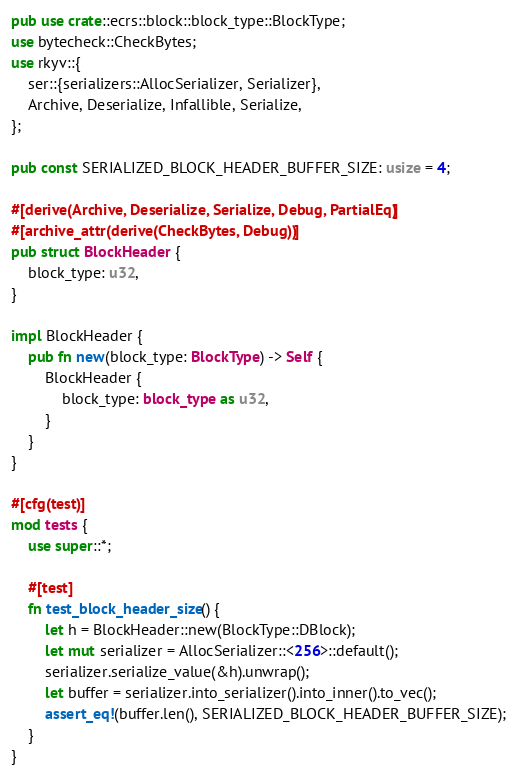Convert code to text. <code><loc_0><loc_0><loc_500><loc_500><_Rust_>pub use crate::ecrs::block::block_type::BlockType;
use bytecheck::CheckBytes;
use rkyv::{
    ser::{serializers::AllocSerializer, Serializer},
    Archive, Deserialize, Infallible, Serialize,
};

pub const SERIALIZED_BLOCK_HEADER_BUFFER_SIZE: usize = 4;

#[derive(Archive, Deserialize, Serialize, Debug, PartialEq)]
#[archive_attr(derive(CheckBytes, Debug))]
pub struct BlockHeader {
    block_type: u32,
}

impl BlockHeader {
    pub fn new(block_type: BlockType) -> Self {
        BlockHeader {
            block_type: block_type as u32,
        }
    }
}

#[cfg(test)]
mod tests {
    use super::*;

    #[test]
    fn test_block_header_size() {
        let h = BlockHeader::new(BlockType::DBlock);
        let mut serializer = AllocSerializer::<256>::default();
        serializer.serialize_value(&h).unwrap();
        let buffer = serializer.into_serializer().into_inner().to_vec();
        assert_eq!(buffer.len(), SERIALIZED_BLOCK_HEADER_BUFFER_SIZE);
    }
}
</code> 